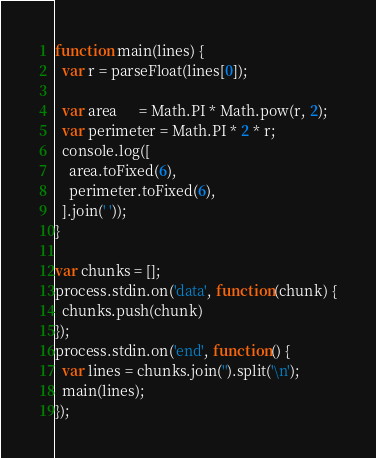Convert code to text. <code><loc_0><loc_0><loc_500><loc_500><_JavaScript_>function main(lines) {
  var r = parseFloat(lines[0]);

  var area      = Math.PI * Math.pow(r, 2);
  var perimeter = Math.PI * 2 * r;
  console.log([
    area.toFixed(6),
    perimeter.toFixed(6),
  ].join(' '));
}

var chunks = [];
process.stdin.on('data', function(chunk) {
  chunks.push(chunk)
});
process.stdin.on('end', function() {
  var lines = chunks.join('').split('\n');
  main(lines);
});</code> 